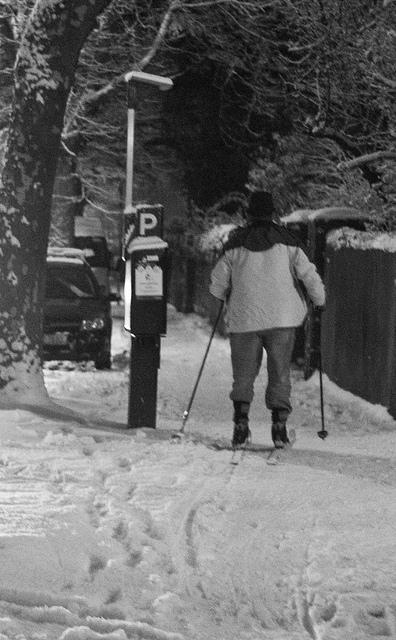What type of area is this?

Choices:
A) mountain
B) residential
C) forest
D) beach residential 